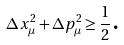Convert formula to latex. <formula><loc_0><loc_0><loc_500><loc_500>\Delta x _ { \mu } ^ { 2 } + \Delta p _ { \mu } ^ { 2 } \geq \frac { 1 } { 2 } \text {.}</formula> 